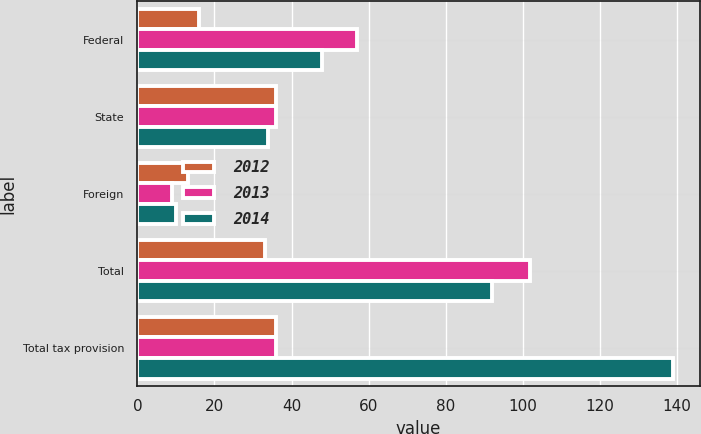Convert chart to OTSL. <chart><loc_0><loc_0><loc_500><loc_500><stacked_bar_chart><ecel><fcel>Federal<fcel>State<fcel>Foreign<fcel>Total<fcel>Total tax provision<nl><fcel>2012<fcel>16<fcel>36<fcel>13<fcel>33<fcel>36<nl><fcel>2013<fcel>57<fcel>36<fcel>9<fcel>102<fcel>36<nl><fcel>2014<fcel>48<fcel>34<fcel>10<fcel>92<fcel>139<nl></chart> 